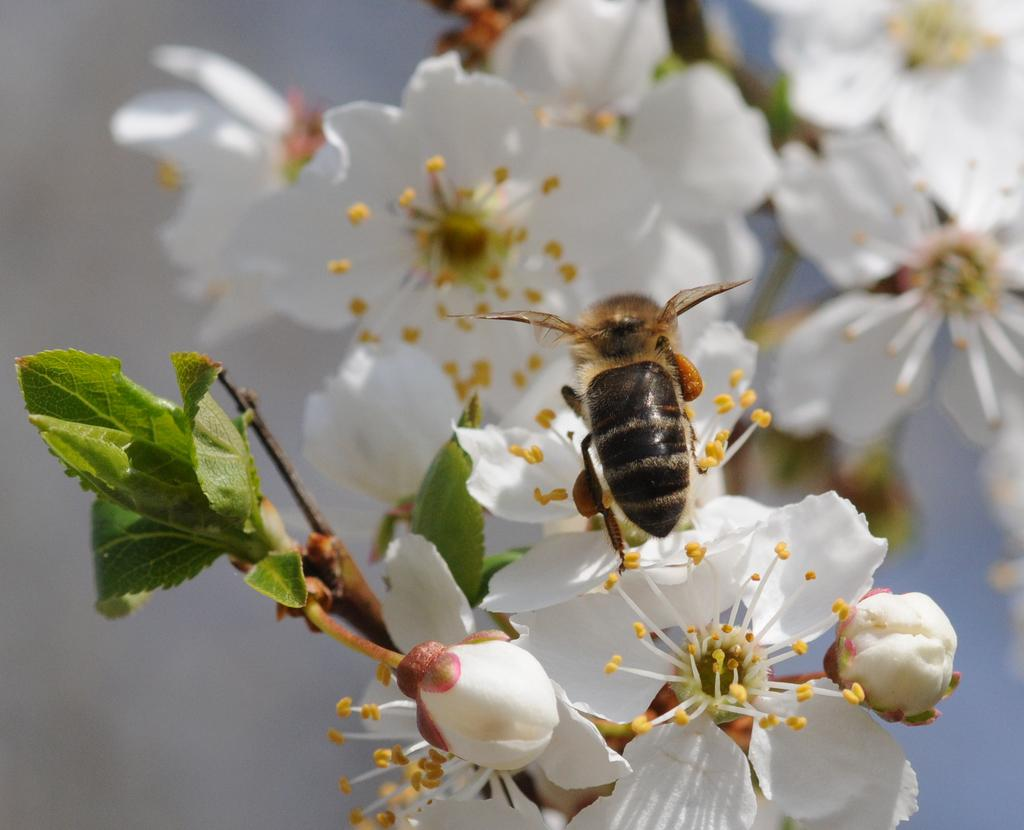What is present on the flower in the image? There is an insect on the flower in the image. What color is the flower that the insect is on? The flower is white. What other elements can be seen in the image besides the insect and flower? There are green leaves in the image. What type of vessel is being used to transport the ice on the flower? There is no vessel or ice present in the image; it features an insect on a white flower with green leaves. 